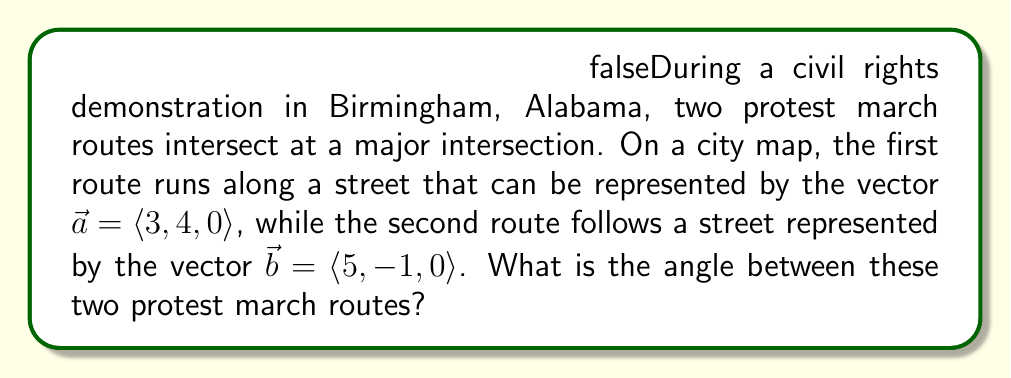Can you solve this math problem? To find the angle between two vectors, we can use the dot product formula:

$$\cos \theta = \frac{\vec{a} \cdot \vec{b}}{|\vec{a}||\vec{b}|}$$

where $\theta$ is the angle between the vectors.

Step 1: Calculate the dot product $\vec{a} \cdot \vec{b}$
$$\vec{a} \cdot \vec{b} = (3)(5) + (4)(-1) + (0)(0) = 15 - 4 = 11$$

Step 2: Calculate the magnitudes of $\vec{a}$ and $\vec{b}$
$$|\vec{a}| = \sqrt{3^2 + 4^2 + 0^2} = \sqrt{9 + 16} = \sqrt{25} = 5$$
$$|\vec{b}| = \sqrt{5^2 + (-1)^2 + 0^2} = \sqrt{25 + 1} = \sqrt{26}$$

Step 3: Substitute into the formula
$$\cos \theta = \frac{11}{5\sqrt{26}}$$

Step 4: Take the inverse cosine (arccos) of both sides
$$\theta = \arccos\left(\frac{11}{5\sqrt{26}}\right)$$

Step 5: Calculate the result (rounded to two decimal places)
$$\theta \approx 0.96 \text{ radians}$$

To convert to degrees, multiply by $\frac{180}{\pi}$:
$$\theta \approx 0.96 \cdot \frac{180}{\pi} \approx 55.15°$$
Answer: $55.15°$ 